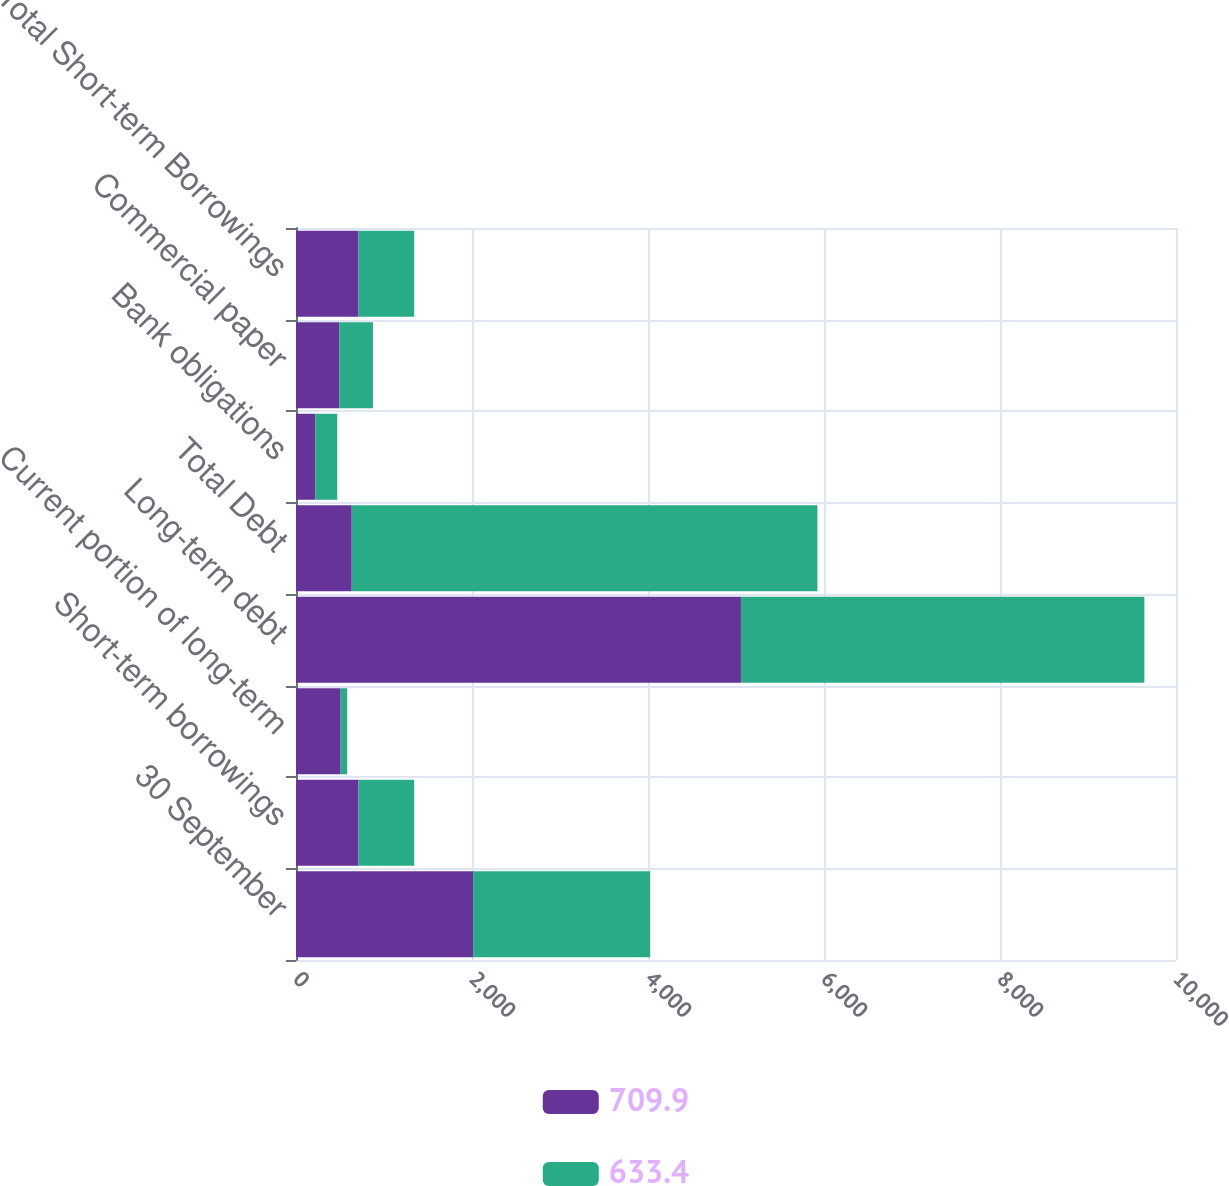<chart> <loc_0><loc_0><loc_500><loc_500><stacked_bar_chart><ecel><fcel>30 September<fcel>Short-term borrowings<fcel>Current portion of long-term<fcel>Long-term debt<fcel>Total Debt<fcel>Bank obligations<fcel>Commercial paper<fcel>Total Short-term Borrowings<nl><fcel>709.9<fcel>2013<fcel>709.9<fcel>507.4<fcel>5056.3<fcel>633.4<fcel>218.9<fcel>491<fcel>709.9<nl><fcel>633.4<fcel>2012<fcel>633.4<fcel>74.3<fcel>4584.2<fcel>5291.9<fcel>249.9<fcel>383.5<fcel>633.4<nl></chart> 